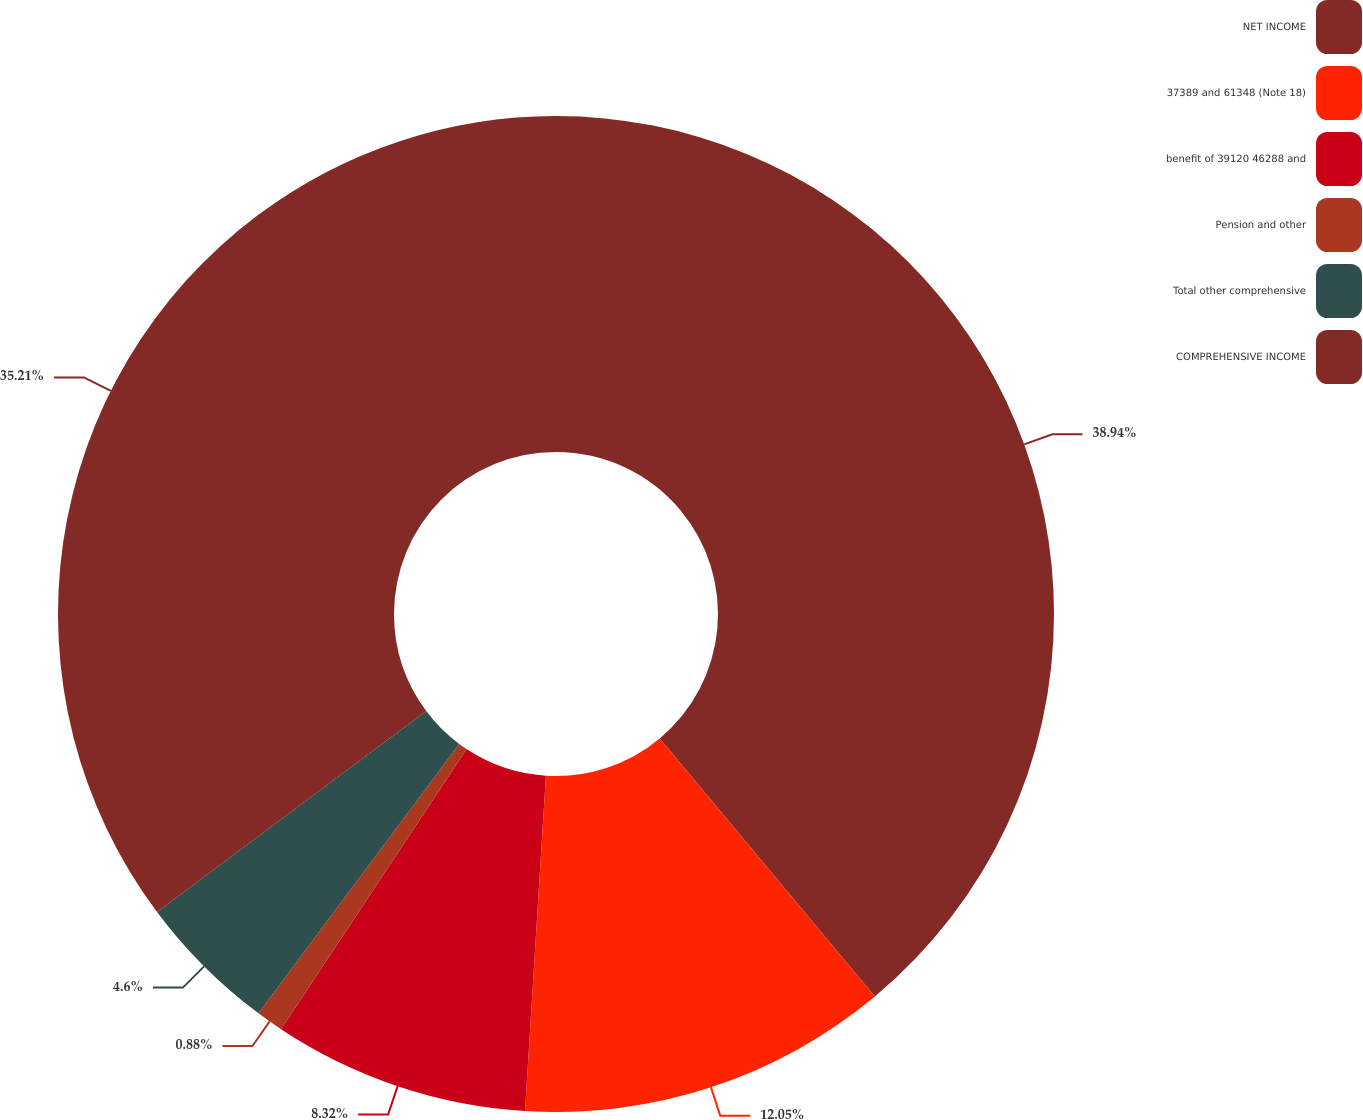Convert chart to OTSL. <chart><loc_0><loc_0><loc_500><loc_500><pie_chart><fcel>NET INCOME<fcel>37389 and 61348 (Note 18)<fcel>benefit of 39120 46288 and<fcel>Pension and other<fcel>Total other comprehensive<fcel>COMPREHENSIVE INCOME<nl><fcel>38.94%<fcel>12.05%<fcel>8.32%<fcel>0.88%<fcel>4.6%<fcel>35.21%<nl></chart> 